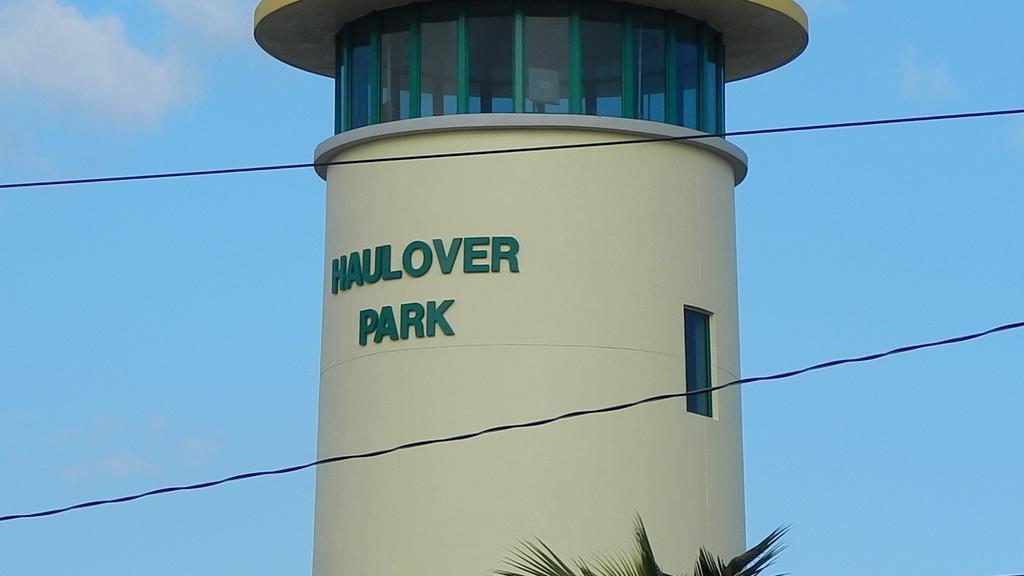How would you summarize this image in a sentence or two? in this picture I can see there is a building and has a glass window and there is something written on it. There is a tree and the sky is clear. 